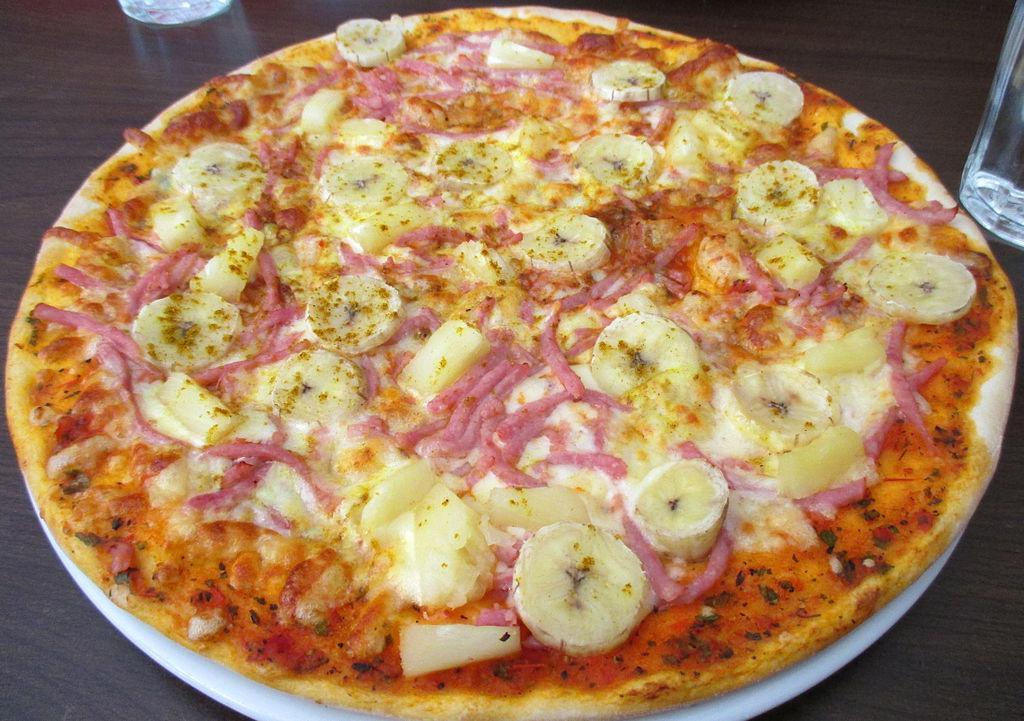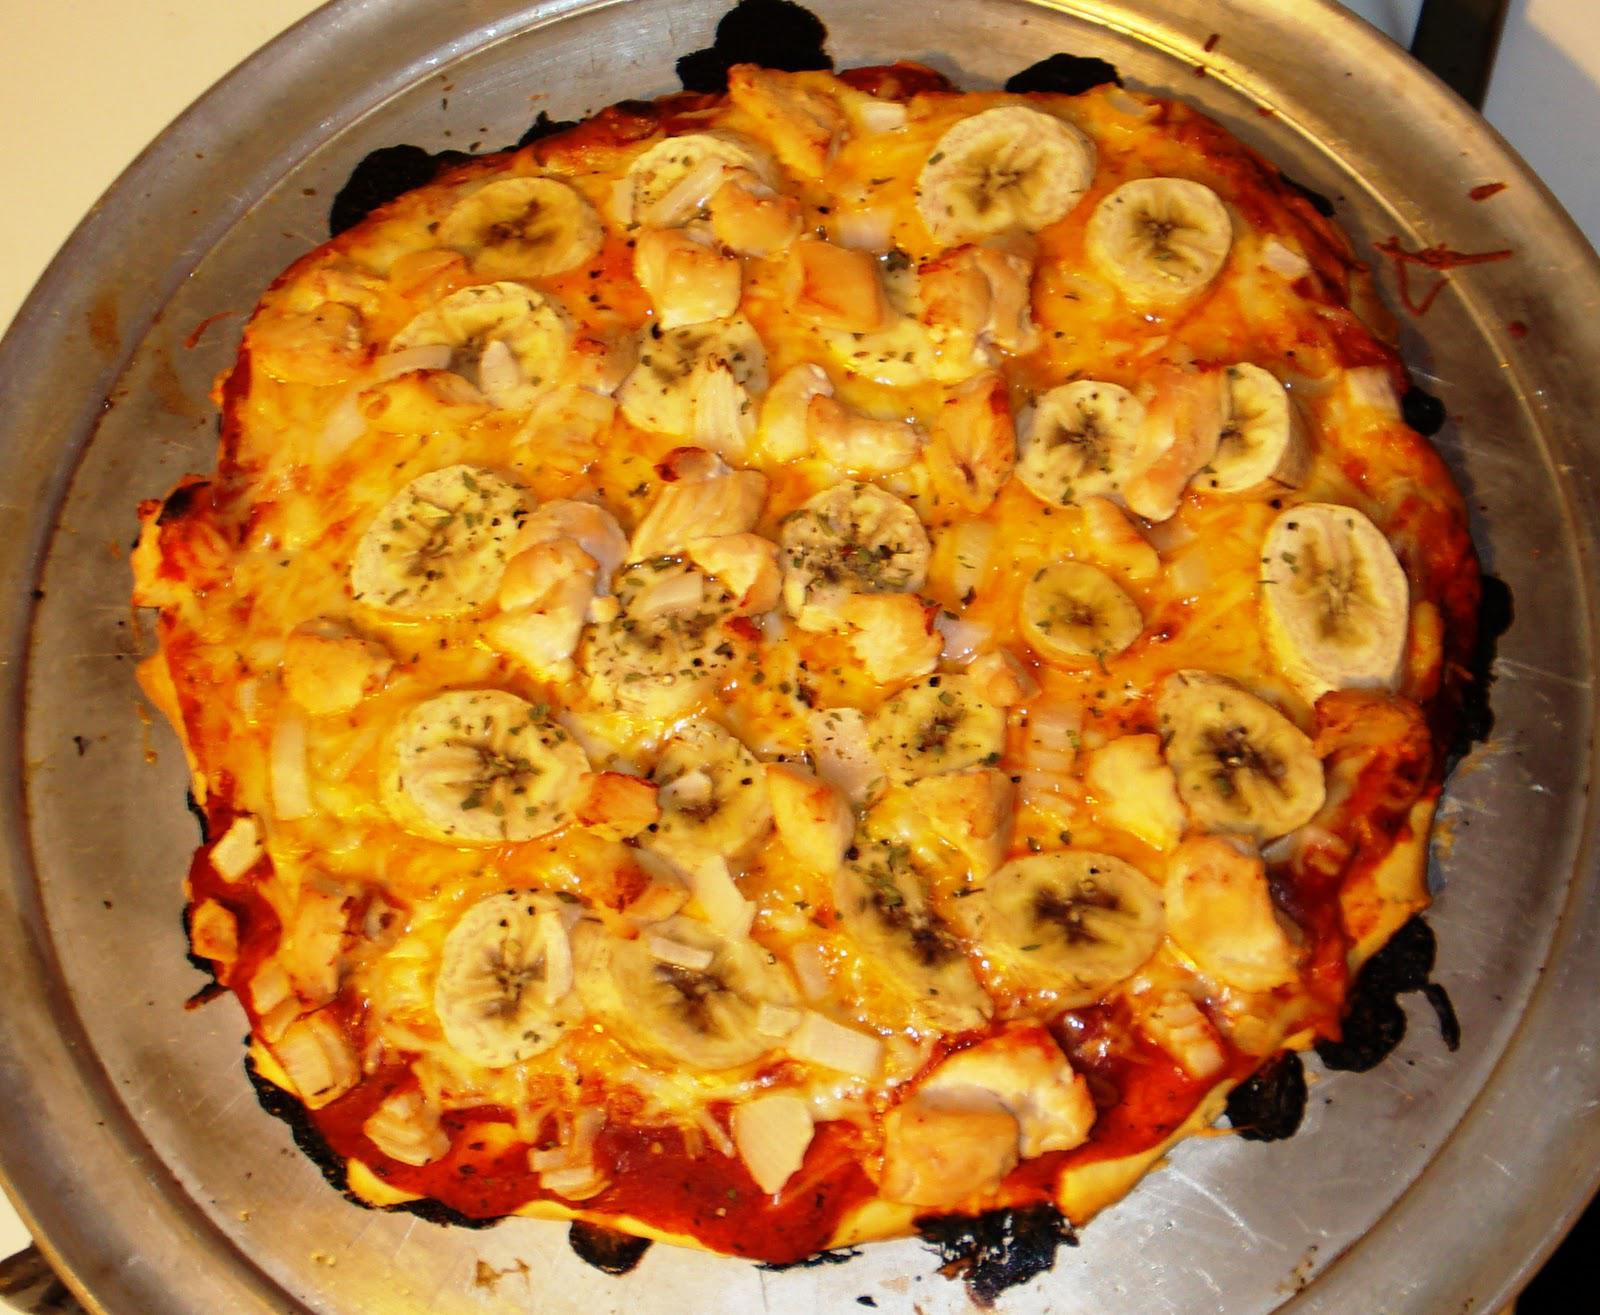The first image is the image on the left, the second image is the image on the right. For the images displayed, is the sentence "One image shows a pizza served on a white platter." factually correct? Answer yes or no. Yes. 